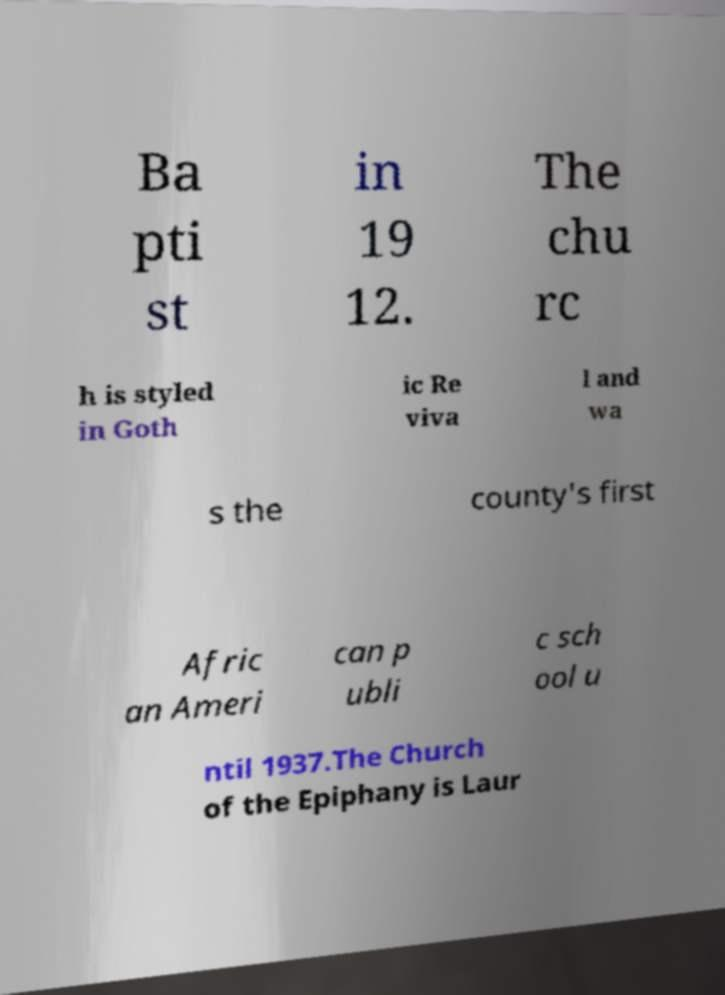Can you read and provide the text displayed in the image?This photo seems to have some interesting text. Can you extract and type it out for me? Ba pti st in 19 12. The chu rc h is styled in Goth ic Re viva l and wa s the county's first Afric an Ameri can p ubli c sch ool u ntil 1937.The Church of the Epiphany is Laur 